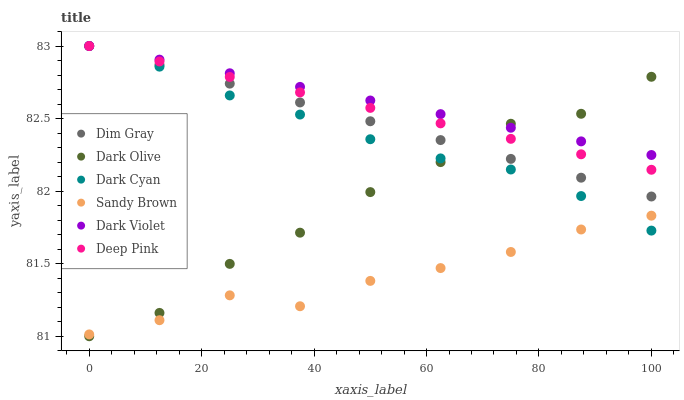Does Sandy Brown have the minimum area under the curve?
Answer yes or no. Yes. Does Dark Violet have the maximum area under the curve?
Answer yes or no. Yes. Does Dark Olive have the minimum area under the curve?
Answer yes or no. No. Does Dark Olive have the maximum area under the curve?
Answer yes or no. No. Is Dark Violet the smoothest?
Answer yes or no. Yes. Is Dark Olive the roughest?
Answer yes or no. Yes. Is Dark Olive the smoothest?
Answer yes or no. No. Is Dark Violet the roughest?
Answer yes or no. No. Does Dark Olive have the lowest value?
Answer yes or no. Yes. Does Dark Violet have the lowest value?
Answer yes or no. No. Does Dark Cyan have the highest value?
Answer yes or no. Yes. Does Dark Olive have the highest value?
Answer yes or no. No. Is Sandy Brown less than Dim Gray?
Answer yes or no. Yes. Is Dark Violet greater than Sandy Brown?
Answer yes or no. Yes. Does Sandy Brown intersect Dark Olive?
Answer yes or no. Yes. Is Sandy Brown less than Dark Olive?
Answer yes or no. No. Is Sandy Brown greater than Dark Olive?
Answer yes or no. No. Does Sandy Brown intersect Dim Gray?
Answer yes or no. No. 